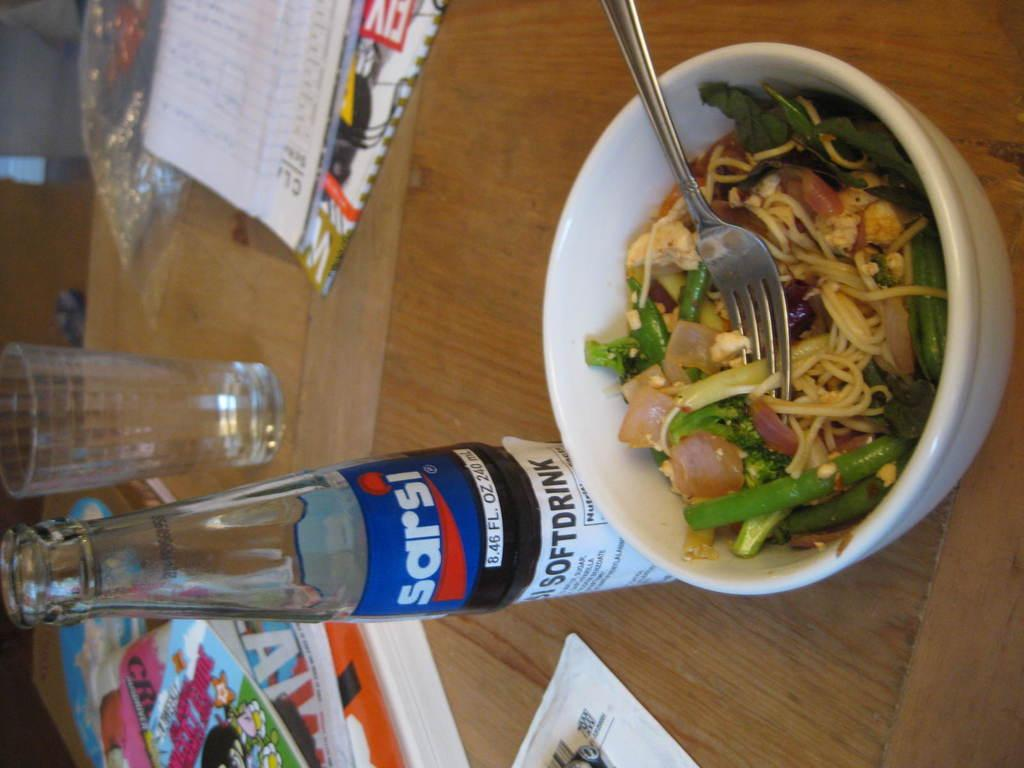<image>
Give a short and clear explanation of the subsequent image. A bottle of Sarsi soft drink sits next to a bowl of food. 